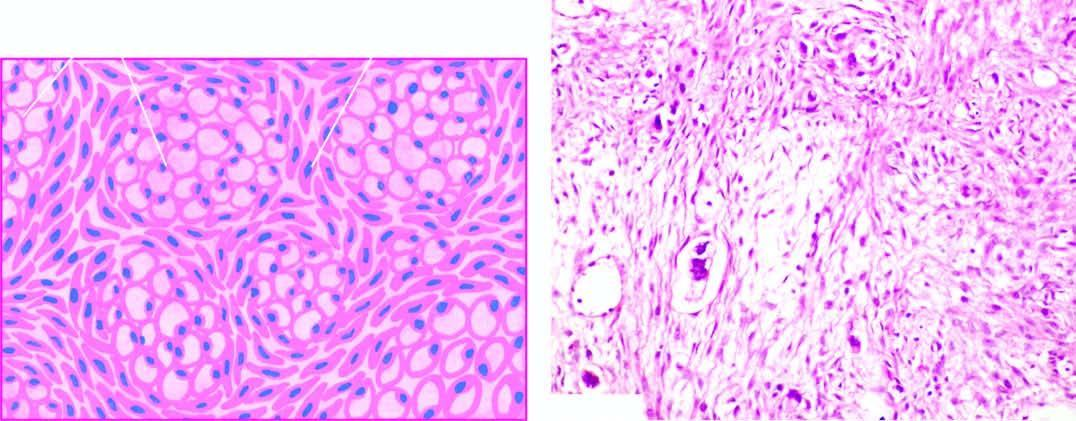do typhoid ulcers in the small intestine include mucin-filled signet-ring cells and richly cellular proliferation of the ovarian stroma?
Answer the question using a single word or phrase. No 